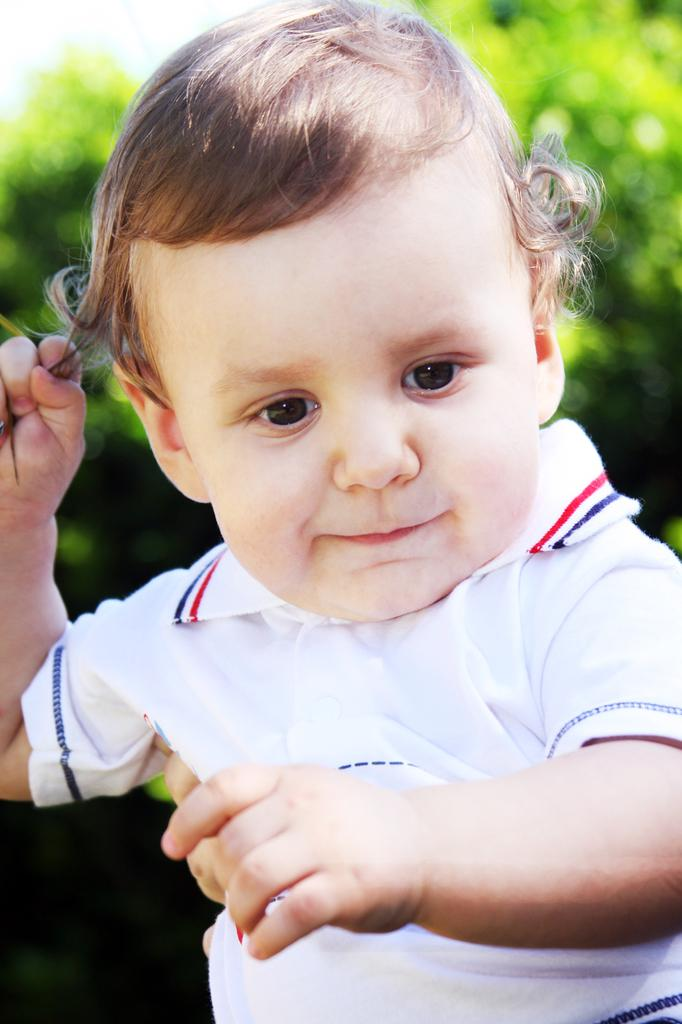What is the main subject of the image? The main subject of the image is a kid. What can be observed about the kid's attire? The kid is wearing clothes. How would you describe the background of the image? The background of the image is blurred. What type of ear is visible on the kid in the image? There is no ear visible on the kid in the image, as the focus is on the kid's face and not their ears. 